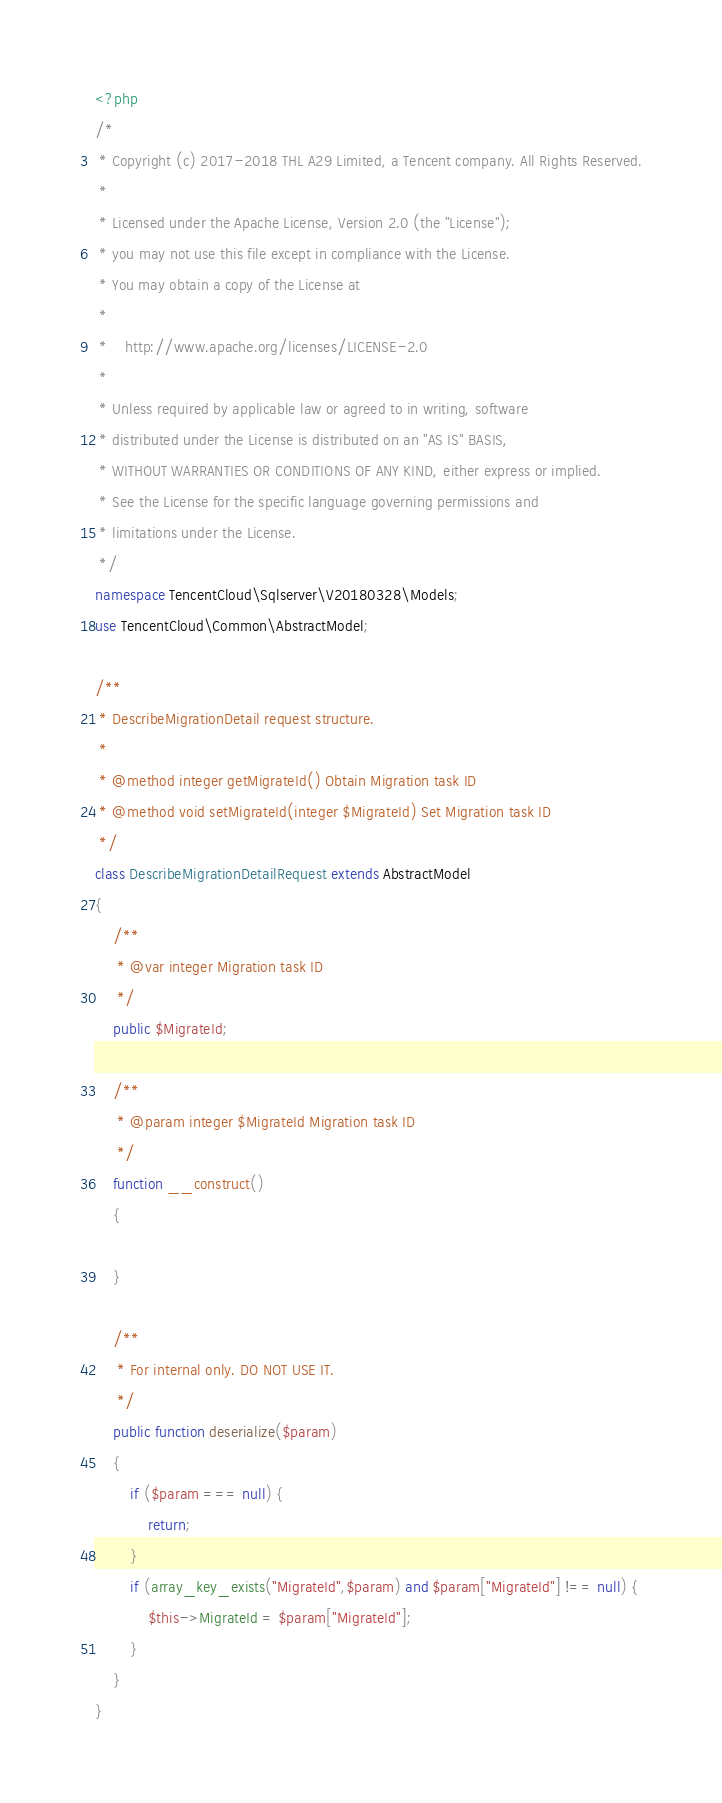Convert code to text. <code><loc_0><loc_0><loc_500><loc_500><_PHP_><?php
/*
 * Copyright (c) 2017-2018 THL A29 Limited, a Tencent company. All Rights Reserved.
 *
 * Licensed under the Apache License, Version 2.0 (the "License");
 * you may not use this file except in compliance with the License.
 * You may obtain a copy of the License at
 *
 *    http://www.apache.org/licenses/LICENSE-2.0
 *
 * Unless required by applicable law or agreed to in writing, software
 * distributed under the License is distributed on an "AS IS" BASIS,
 * WITHOUT WARRANTIES OR CONDITIONS OF ANY KIND, either express or implied.
 * See the License for the specific language governing permissions and
 * limitations under the License.
 */
namespace TencentCloud\Sqlserver\V20180328\Models;
use TencentCloud\Common\AbstractModel;

/**
 * DescribeMigrationDetail request structure.
 *
 * @method integer getMigrateId() Obtain Migration task ID
 * @method void setMigrateId(integer $MigrateId) Set Migration task ID
 */
class DescribeMigrationDetailRequest extends AbstractModel
{
    /**
     * @var integer Migration task ID
     */
    public $MigrateId;

    /**
     * @param integer $MigrateId Migration task ID
     */
    function __construct()
    {

    }

    /**
     * For internal only. DO NOT USE IT.
     */
    public function deserialize($param)
    {
        if ($param === null) {
            return;
        }
        if (array_key_exists("MigrateId",$param) and $param["MigrateId"] !== null) {
            $this->MigrateId = $param["MigrateId"];
        }
    }
}
</code> 